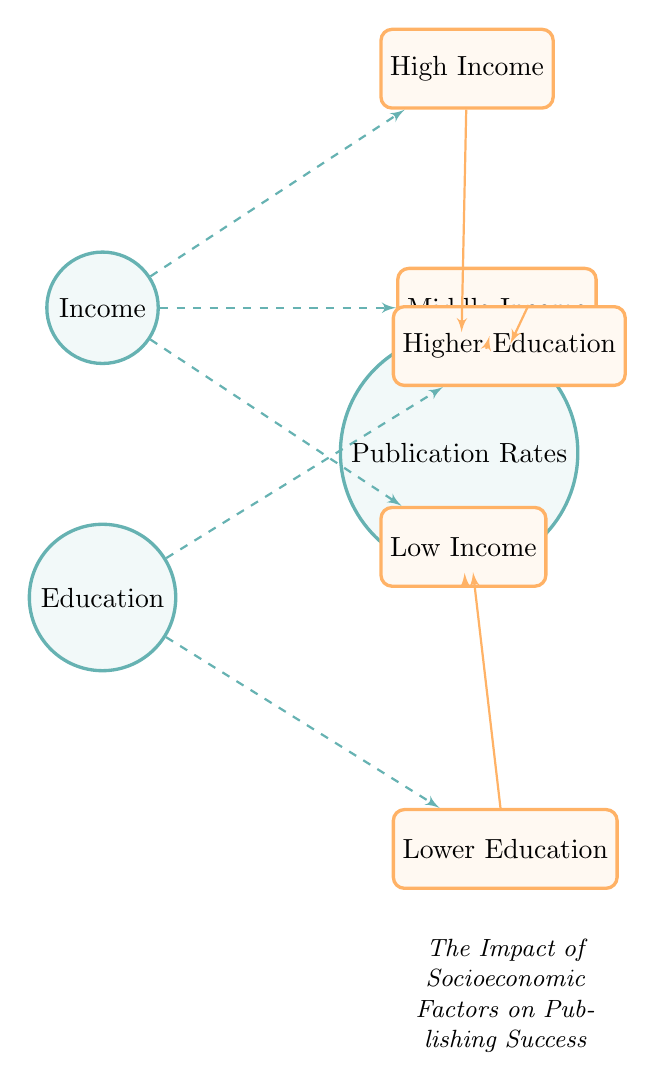What are the three categories of income in the diagram? The diagram explicitly lists three categories for income: High Income, Middle Income, and Low Income, represented as sub-nodes connected to the Income main node.
Answer: High Income, Middle Income, Low Income How many nodes are there in total? The diagram contains one main node for Income, one main node for Education, one main node for Publication Rates, and four sub-nodes (three for Income and two for Education), totaling seven nodes.
Answer: Seven What is the relationship between High Income and Publication Rates? The diagram illustrates a correlation edge from the High Income sub-node to the Publication Rates node, indicating a relationship where higher income is associated with higher publication rates.
Answer: Correlation Which education level is connected directly to Publication Rates? Both Higher Education and Lower Education nodes are connected with a correlation edge to the Publication Rates node, suggesting that education level influences publication success regardless of whether it is higher or lower.
Answer: Both Higher Education and Lower Education How many correlation edges are there in the diagram? The diagram shows correlation edges going from High Income to Publication Rates, Middle Income to Publication Rates, Low Income to Publication Rates, Higher Education to Publication Rates, and Lower Education to Publication Rates, totaling five correlation edges.
Answer: Five What is the purpose of the dashed edges in the diagram? The dashed edges, labeled as category edges, connect the main nodes to their sub-categories, highlighting the classification of income and education levels, rather than indicating a correlation.
Answer: Category edges Is there a direct correlation between Lower Education and Publication Rates? Yes, the diagram indicates a direct correlation edge between the Lower Education sub-node and the Publication Rates node, showing that there is an influence of lower education on publication success.
Answer: Yes Which sub-node is on the lower right of the Education node? The Lower Education sub-node is positioned directly below the Education main node and to its right, indicating the lower level of education.
Answer: Lower Education 